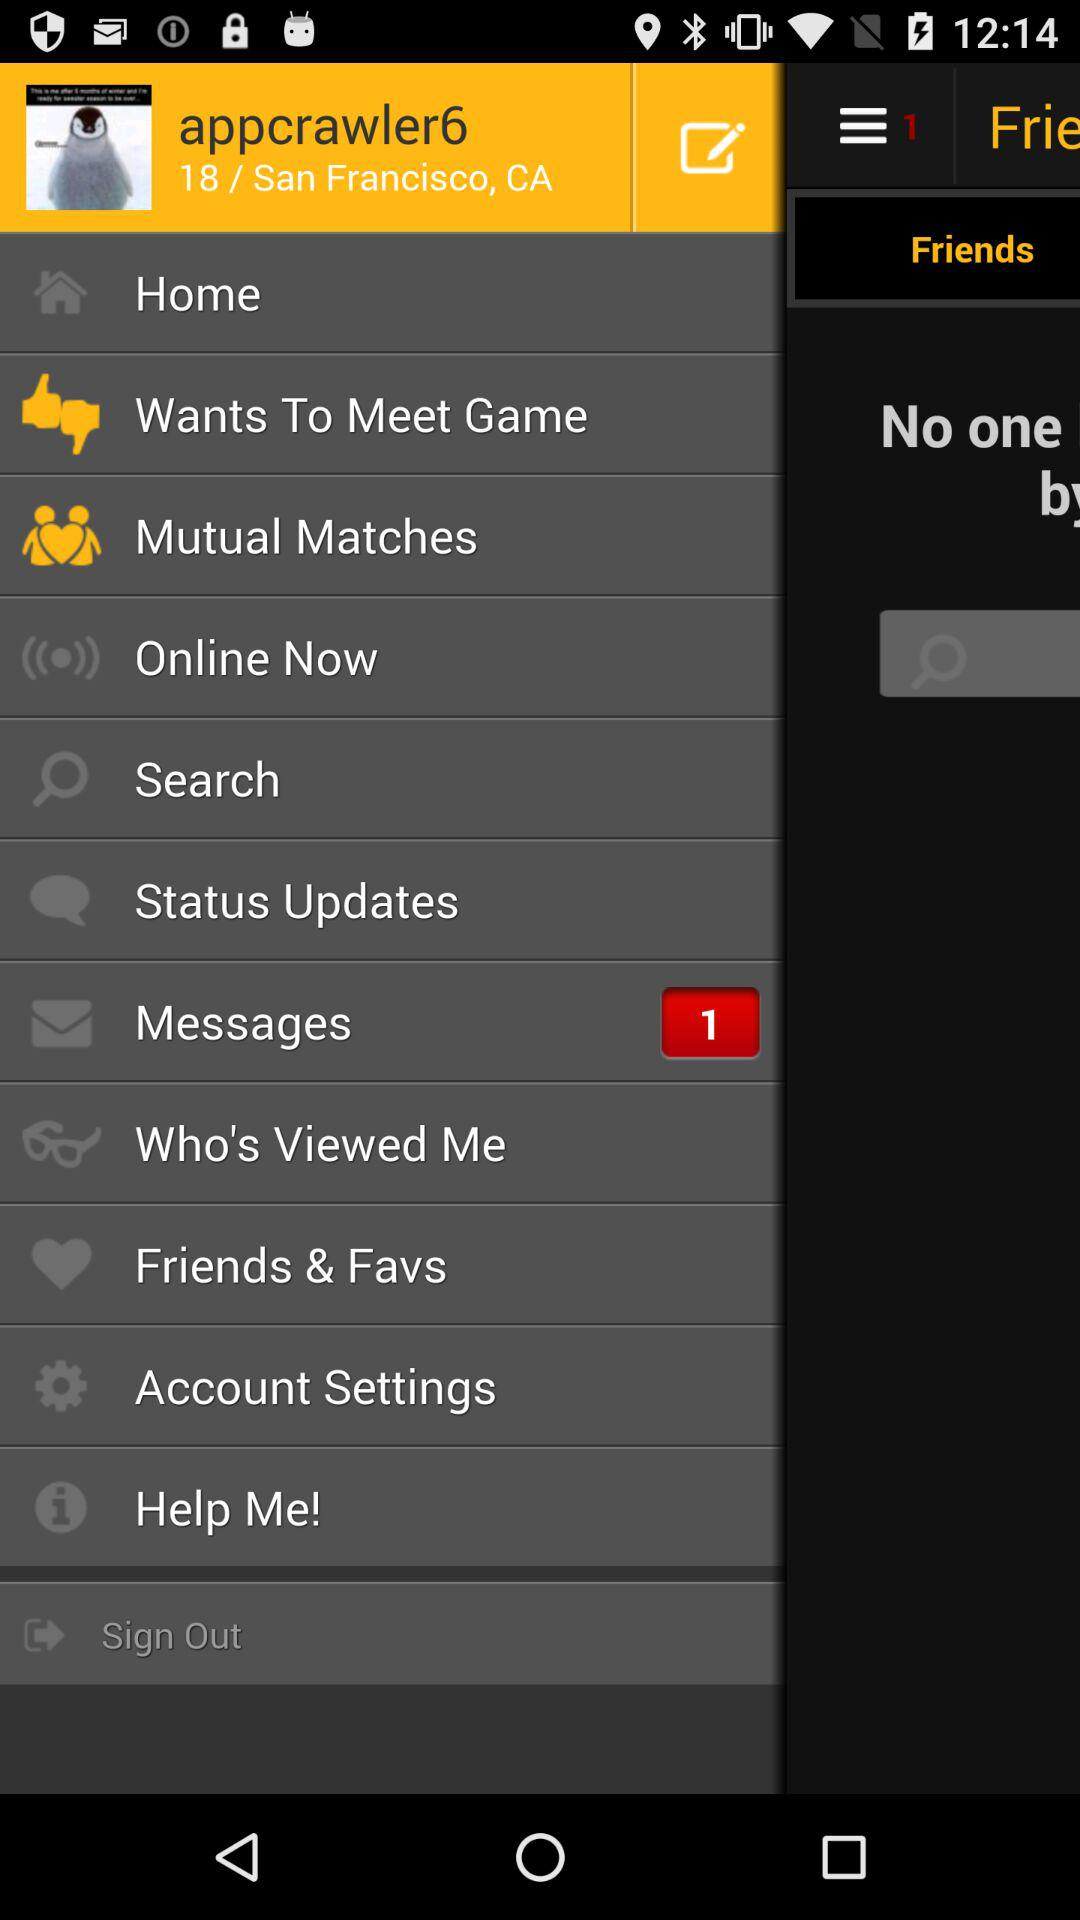How many unread messages are there? There is 1 unread message. 